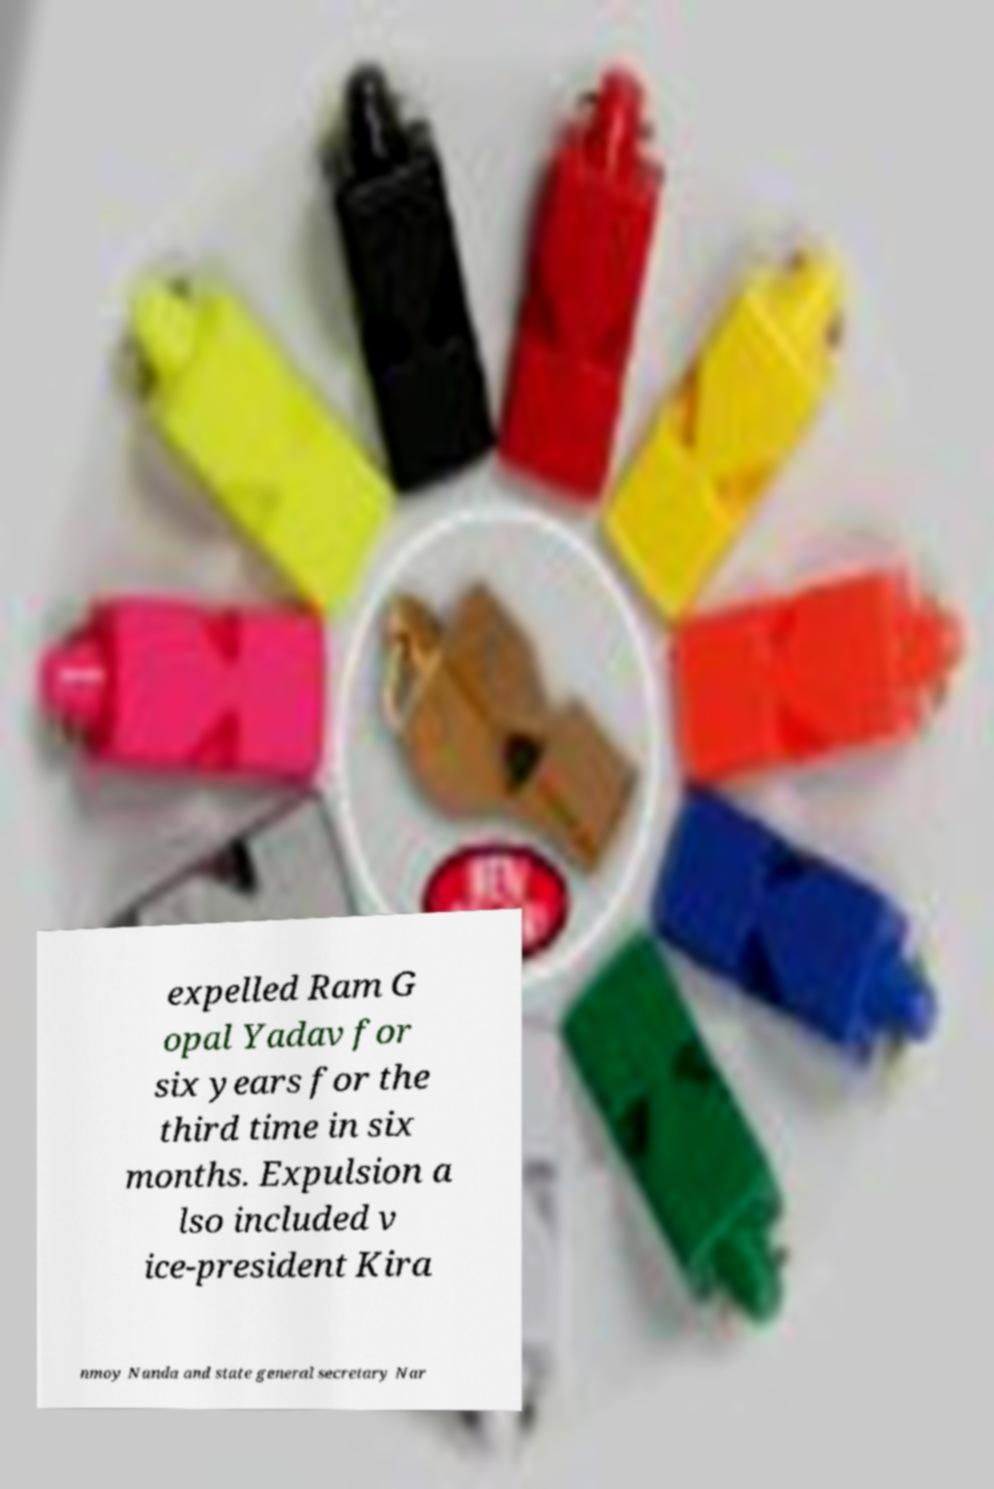What messages or text are displayed in this image? I need them in a readable, typed format. expelled Ram G opal Yadav for six years for the third time in six months. Expulsion a lso included v ice-president Kira nmoy Nanda and state general secretary Nar 